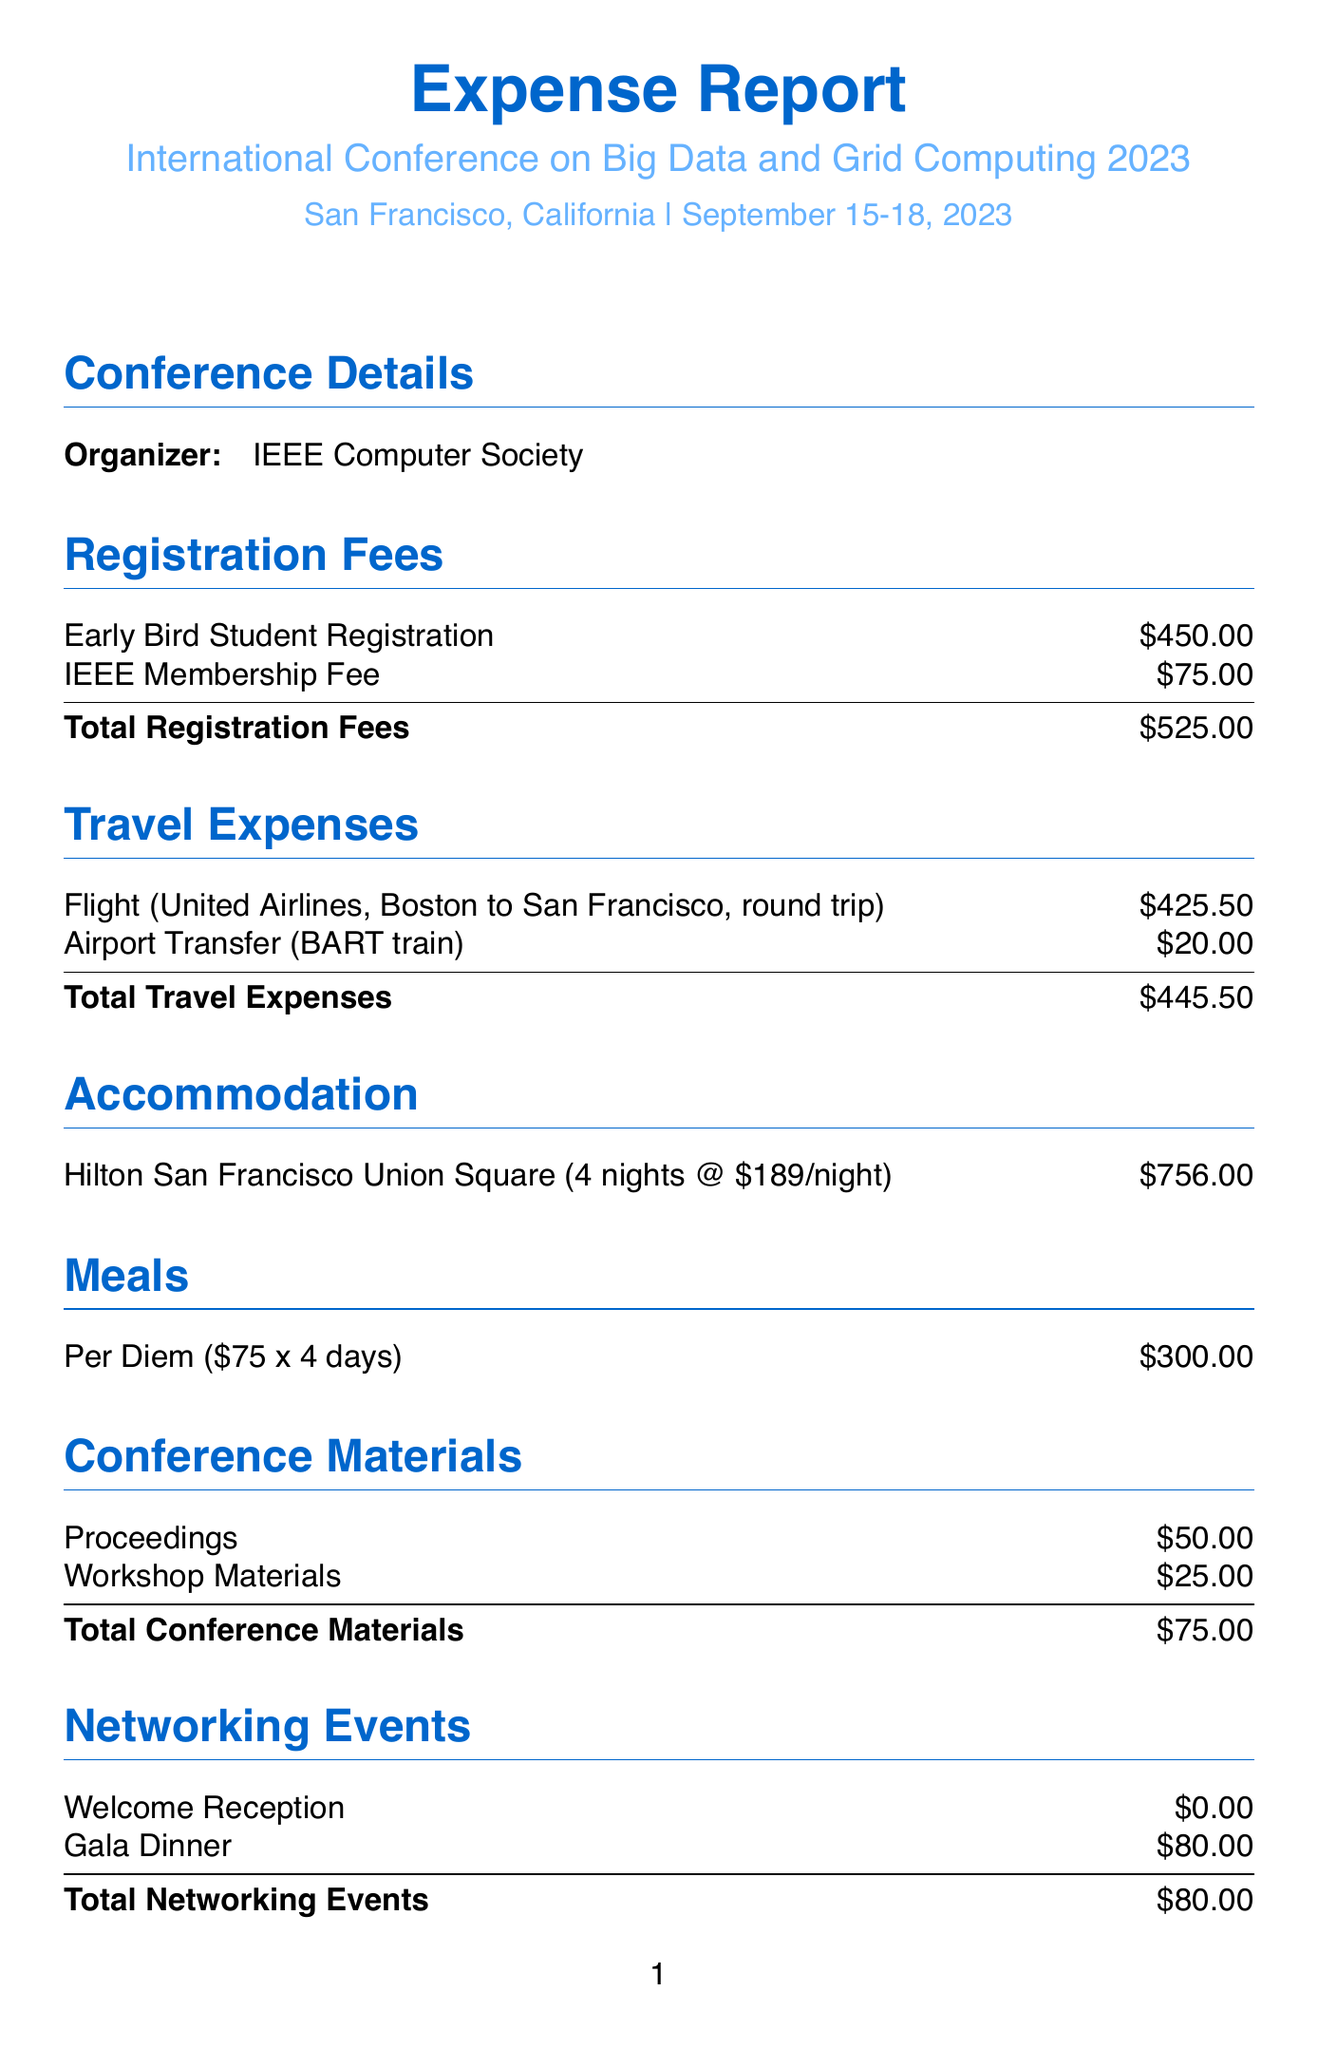What is the name of the conference? The name of the conference is clearly stated in the document, which is "International Conference on Big Data and Grid Computing 2023."
Answer: International Conference on Big Data and Grid Computing 2023 Where is the conference located? The location of the conference is provided in the document, which is San Francisco, California.
Answer: San Francisco, California What is the total cost of accommodation? The total cost of accommodation can be found in the accommodation section, which mentions four nights at $189 per night, totaling $756.
Answer: $756 What is the total cost of meals? The meals section of the document specifies the per diem and the number of days, leading to a total meal expense of $300.
Answer: $300 How much did the gala dinner cost? The gala dinner cost is listed under the networking events section, which shows a cost of $80.
Answer: $80 What is the cost of the hands-on grid computing workshop? The cost of the workshop can be found in the professional development section and is stated as $200.
Answer: $200 What was the total travel expense? The total travel expense is the sum of the flight and airport transfer costs outlined in the travel expenses section, totaling $445.50.
Answer: $445.50 What is the total expense reported? The total expenses amount is stated at the end of the document, which sums up all the expenses to $2982.50.
Answer: $2982.50 What is included in the conference materials cost? Under the conference materials section, the costs of proceedings at $50 and workshop materials at $25 make up the total of $75.
Answer: Proceedings and workshop materials 